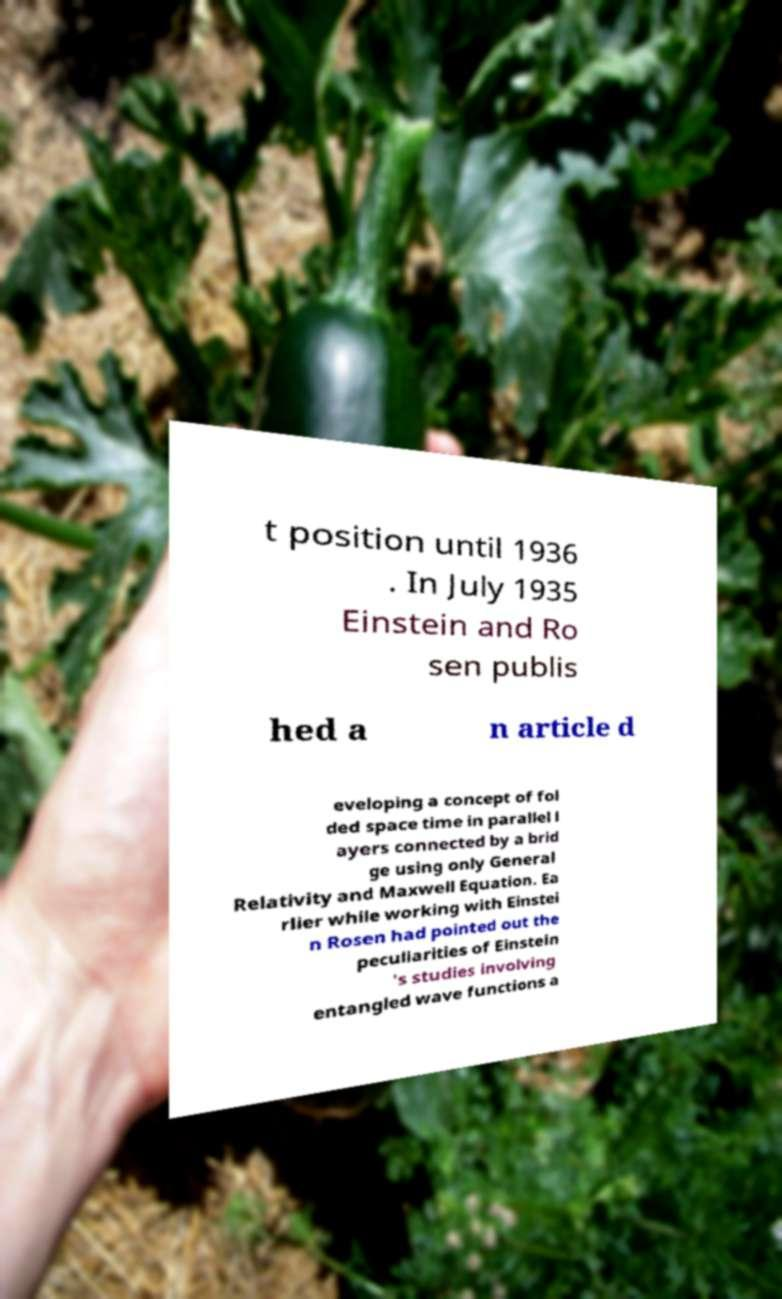Please identify and transcribe the text found in this image. t position until 1936 . In July 1935 Einstein and Ro sen publis hed a n article d eveloping a concept of fol ded space time in parallel l ayers connected by a brid ge using only General Relativity and Maxwell Equation. Ea rlier while working with Einstei n Rosen had pointed out the peculiarities of Einstein 's studies involving entangled wave functions a 